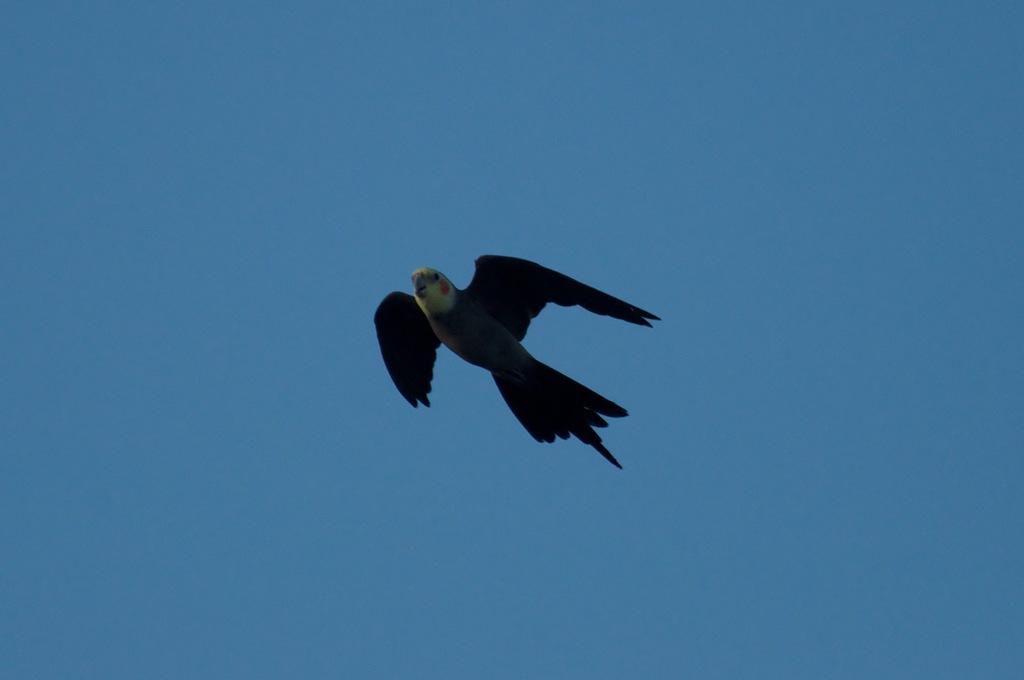What type of animal can be seen in the image? There is a bird in the image. What color is the bird? The bird is black in color. What is the bird doing in the image? The bird is flying in the sky. What can be seen in the background of the image? The sky is visible in the background of the image. What is the color of the sky? The sky is blue in color. Can you tell me how many ladybugs are present in the image? There are no ladybugs present in the image; it features a black bird flying in the blue sky. 